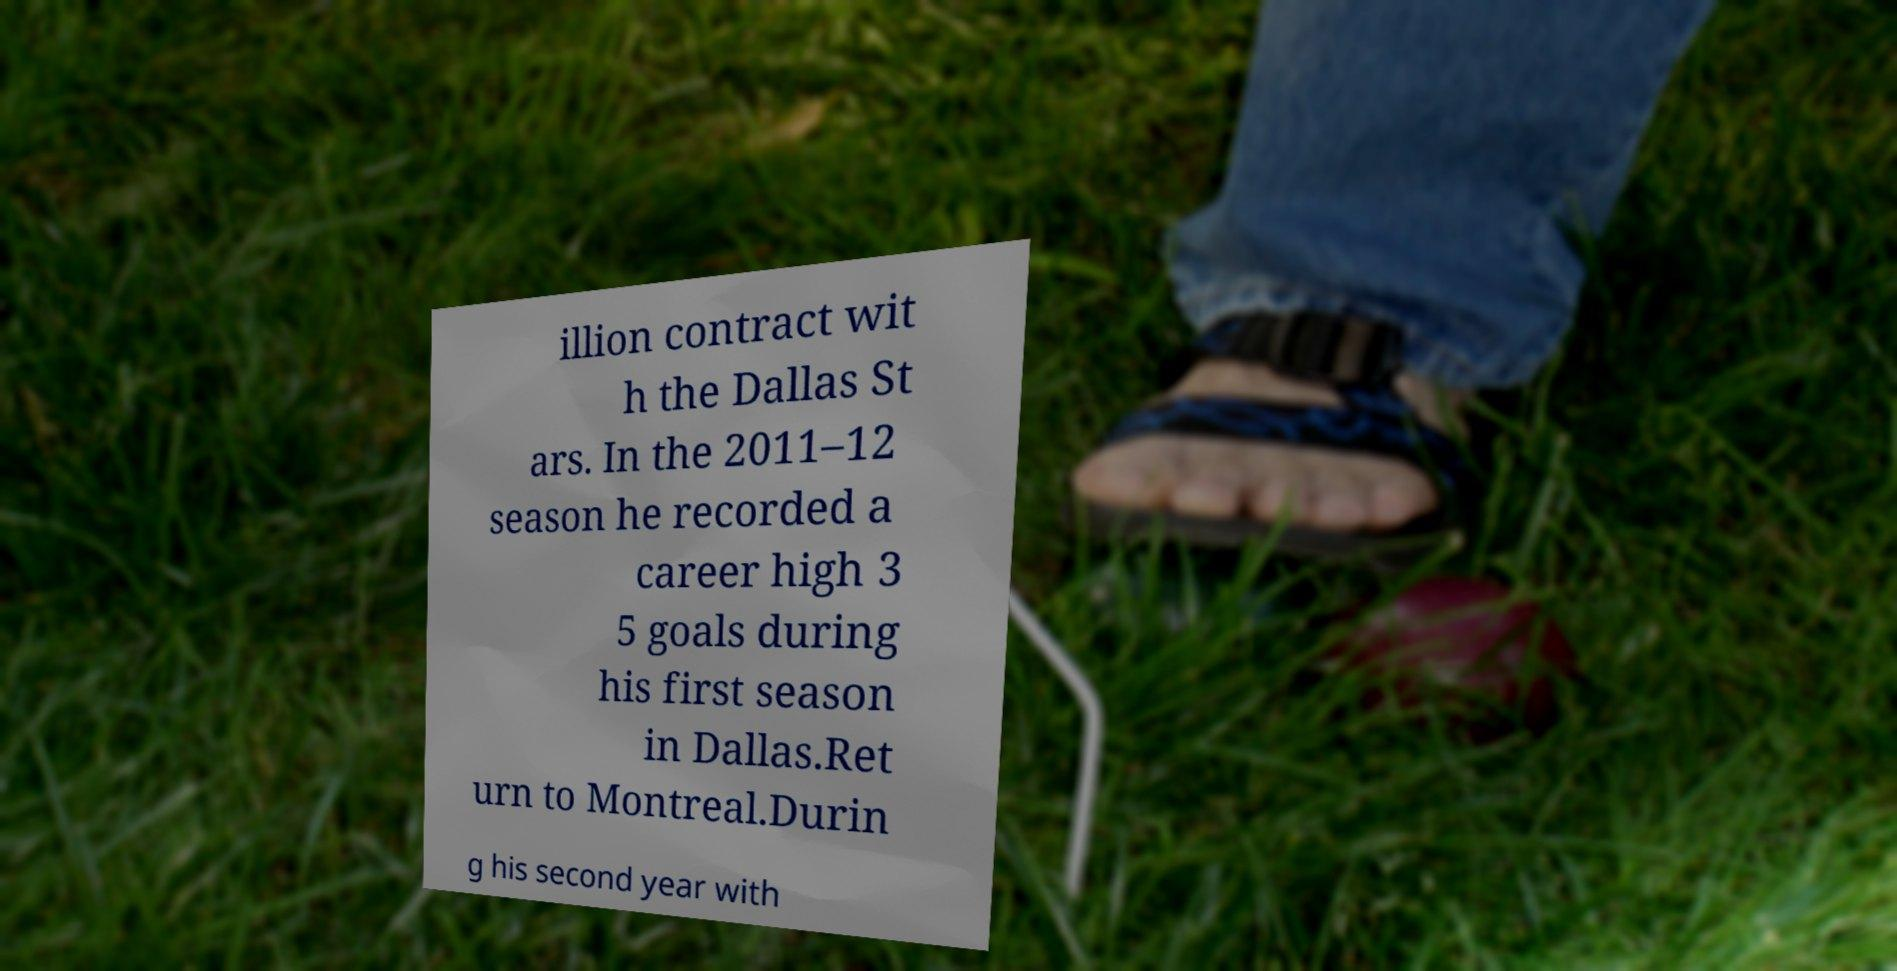For documentation purposes, I need the text within this image transcribed. Could you provide that? illion contract wit h the Dallas St ars. In the 2011–12 season he recorded a career high 3 5 goals during his first season in Dallas.Ret urn to Montreal.Durin g his second year with 